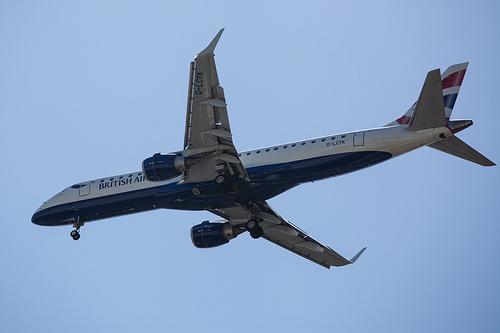How many planes are in the air?
Give a very brief answer. 1. 